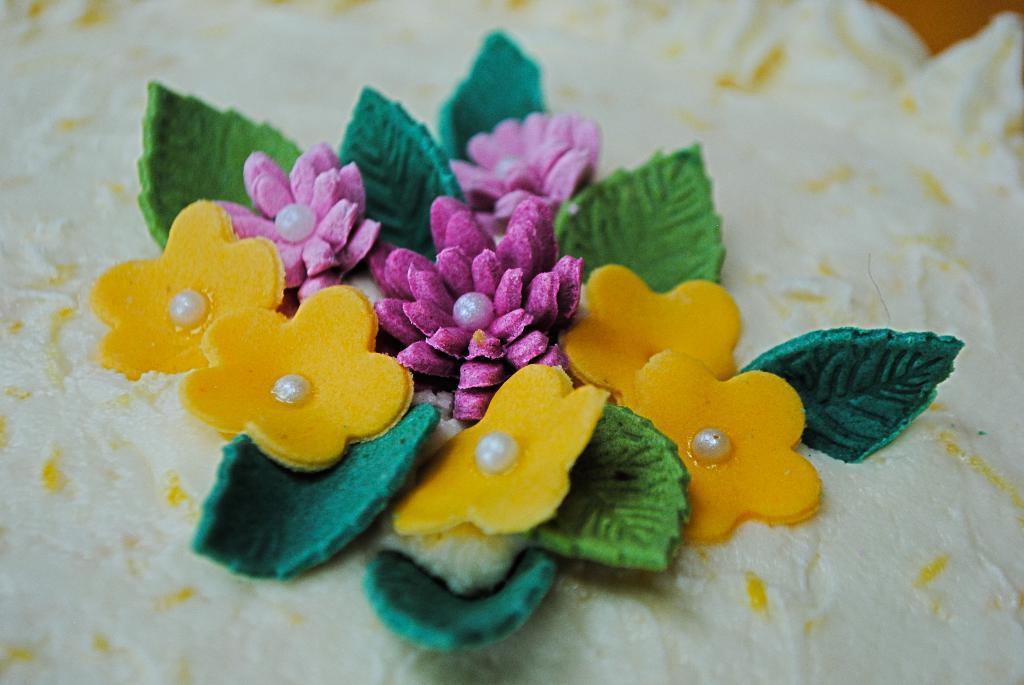Can you describe this image briefly? In this image there is a material having artificial flowers and leaves. 